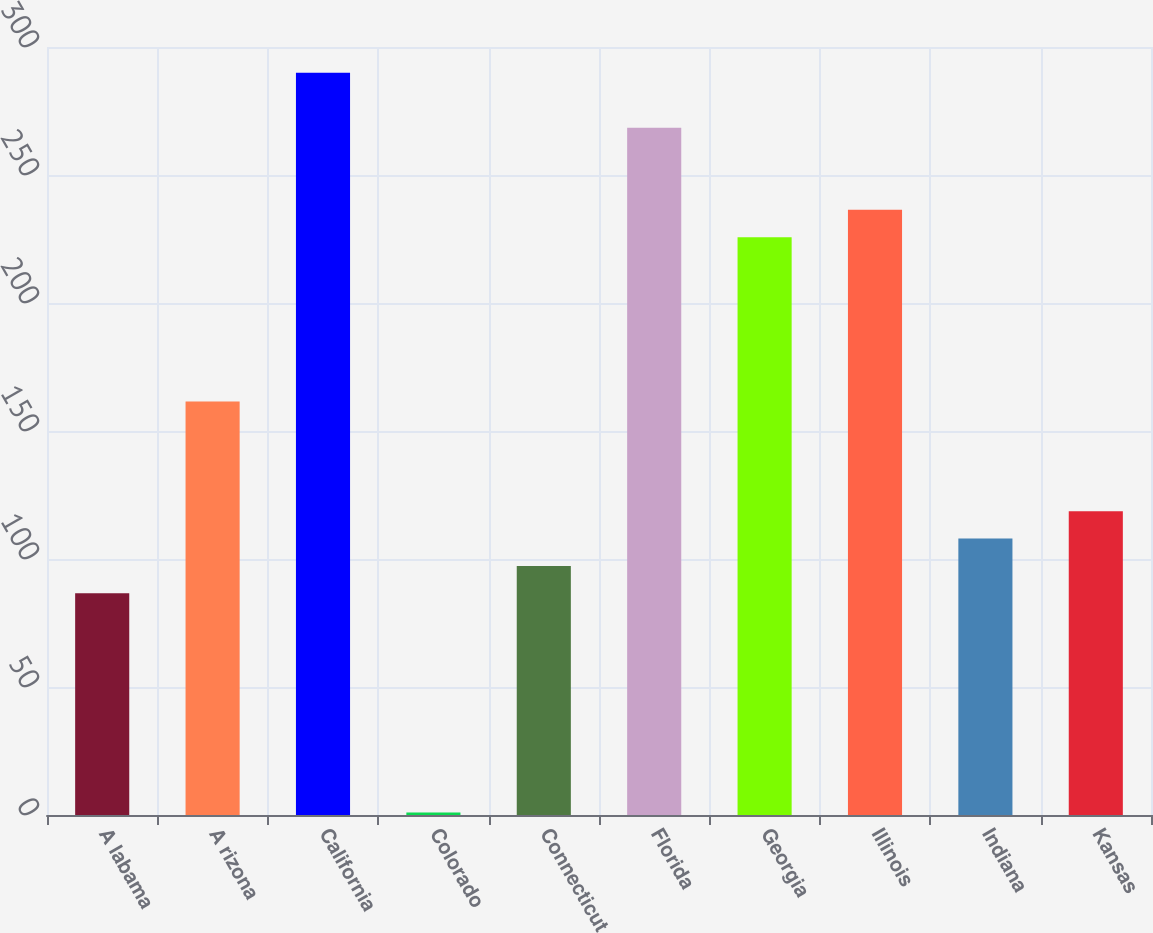Convert chart. <chart><loc_0><loc_0><loc_500><loc_500><bar_chart><fcel>A labama<fcel>A rizona<fcel>California<fcel>Colorado<fcel>Connecticut<fcel>Florida<fcel>Georgia<fcel>Illinois<fcel>Indiana<fcel>Kansas<nl><fcel>86.6<fcel>161.5<fcel>289.9<fcel>1<fcel>97.3<fcel>268.5<fcel>225.7<fcel>236.4<fcel>108<fcel>118.7<nl></chart> 